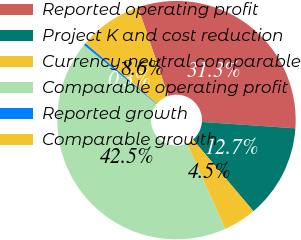Convert chart. <chart><loc_0><loc_0><loc_500><loc_500><pie_chart><fcel>Reported operating profit<fcel>Project K and cost reduction<fcel>Currency-neutral comparable<fcel>Comparable operating profit<fcel>Reported growth<fcel>Comparable growth<nl><fcel>31.32%<fcel>12.74%<fcel>4.47%<fcel>42.55%<fcel>0.33%<fcel>8.6%<nl></chart> 